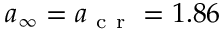<formula> <loc_0><loc_0><loc_500><loc_500>{ a } _ { \infty } = { a } _ { c r } = 1 . 8 6</formula> 